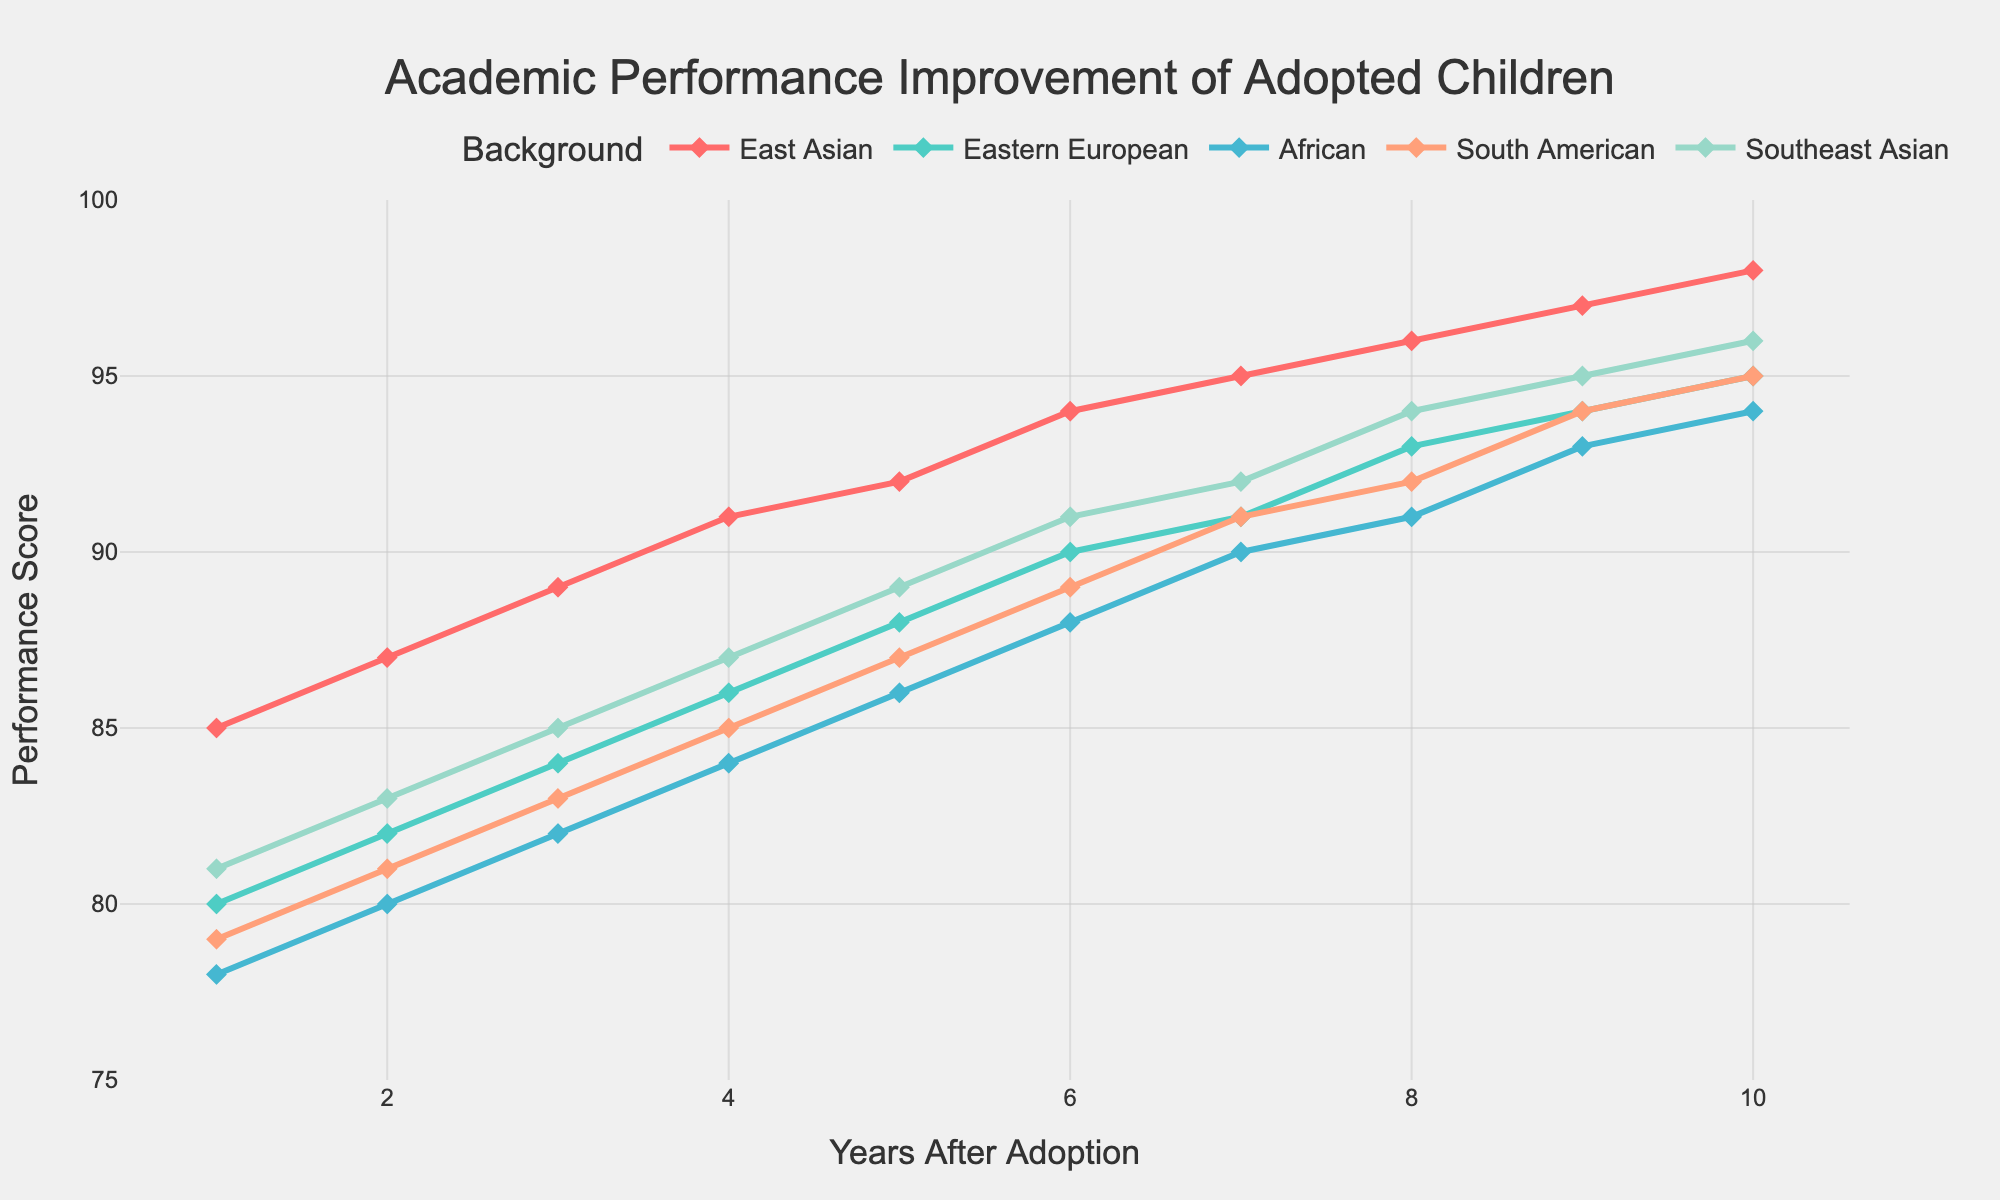Which group shows the highest academic performance in Year 5? Refer to Year 5 data in the plot. Identify each group's performance score. The highest score is from East Asian with 92.
Answer: East Asian How much did the academic performance score of Southeast Asian children improve from Year 1 to Year 10? Identify the scores for Southeast Asian children in Year 1 (81) and Year 10 (96). Subtract the Year 1 score from the Year 10 score (96 - 81).
Answer: 15 Which group had the least improvement between Year 3 and Year 6? Check all group scores for Year 3 and Year 6. Calculate the differences: East Asian (94-89=5), Eastern European (90-84=6), African (88-82=6), South American (89-83=6), Southeast Asian (91-85=6). East Asian had the least improvement with 5 points.
Answer: East Asian What is the average academic performance score of South American children over the 10 years? Sum the scores for South American children over 10 years and divide by 10: (79+81+83+85+87+89+91+92+94+95)/10 = 87.6
Answer: 87.6 Did African children ever have a higher performance score than Eastern European children during the 10 years? Compare yearly scores of African children and Eastern European children. African scores are consistently lower than Eastern European scores.
Answer: No At which year did East Asian children surpass a score of 90? Review the plot for East Asian children. They surpassed 90 in Year 4 with a score of 91.
Answer: Year 4 Which group experienced the steepest rise in performance score between any two consecutive years? Calculate yearly increases for all groups, identify the steepest rise: Southeast Asian from Year 1 to 2 (83-81=2); others had smaller increases between any two consecutive years.
Answer: Southeast Asian What is the difference in performance scores between the highest and lowest scoring groups in Year 9? Identify scores in Year 9: East Asian (97), Eastern European (94), African (93), South American (94), Southeast Asian (95). Difference between highest (East Asian) and lowest (African) is 97-93=4.
Answer: 4 